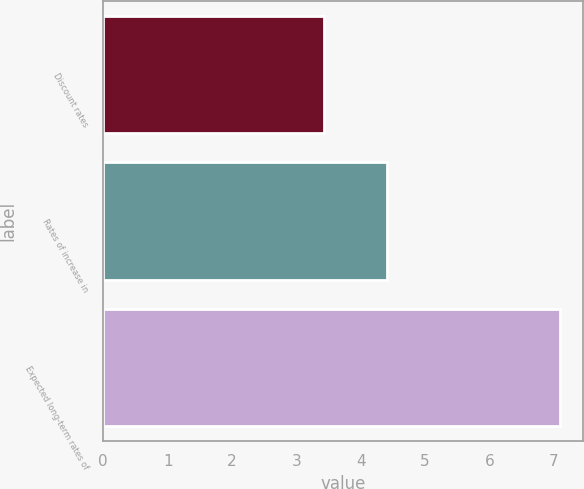Convert chart. <chart><loc_0><loc_0><loc_500><loc_500><bar_chart><fcel>Discount rates<fcel>Rates of increase in<fcel>Expected long-term rates of<nl><fcel>3.43<fcel>4.41<fcel>7.1<nl></chart> 